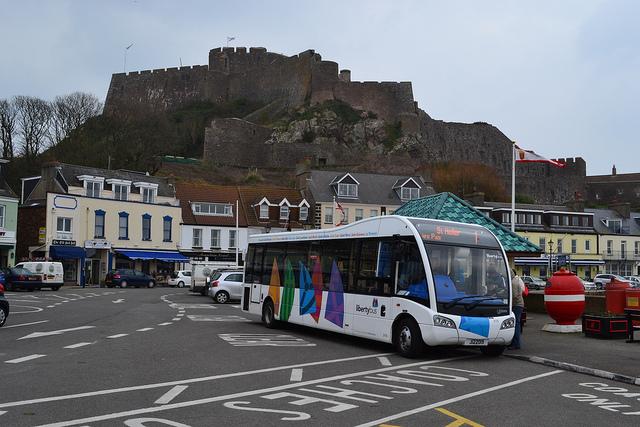Is this a city or countryside?
Short answer required. City. What is on the hill?
Be succinct. Castle. What is written on the pavement at the front of and facing the bus?
Give a very brief answer. Coaches. Do all of the buildings in this picture appear to have been built within the past 100 years?
Be succinct. No. 